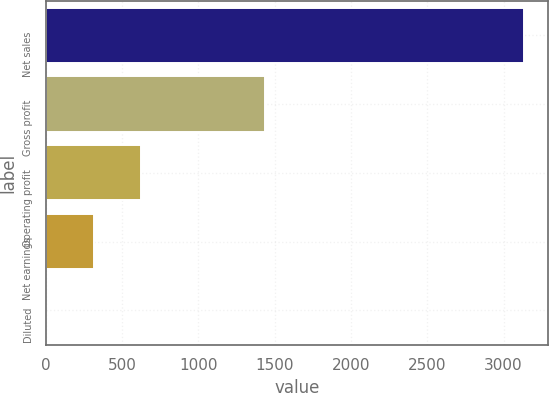Convert chart. <chart><loc_0><loc_0><loc_500><loc_500><bar_chart><fcel>Net sales<fcel>Gross profit<fcel>Operating profit<fcel>Net earnings<fcel>Diluted<nl><fcel>3132.9<fcel>1438.4<fcel>626.9<fcel>313.65<fcel>0.4<nl></chart> 